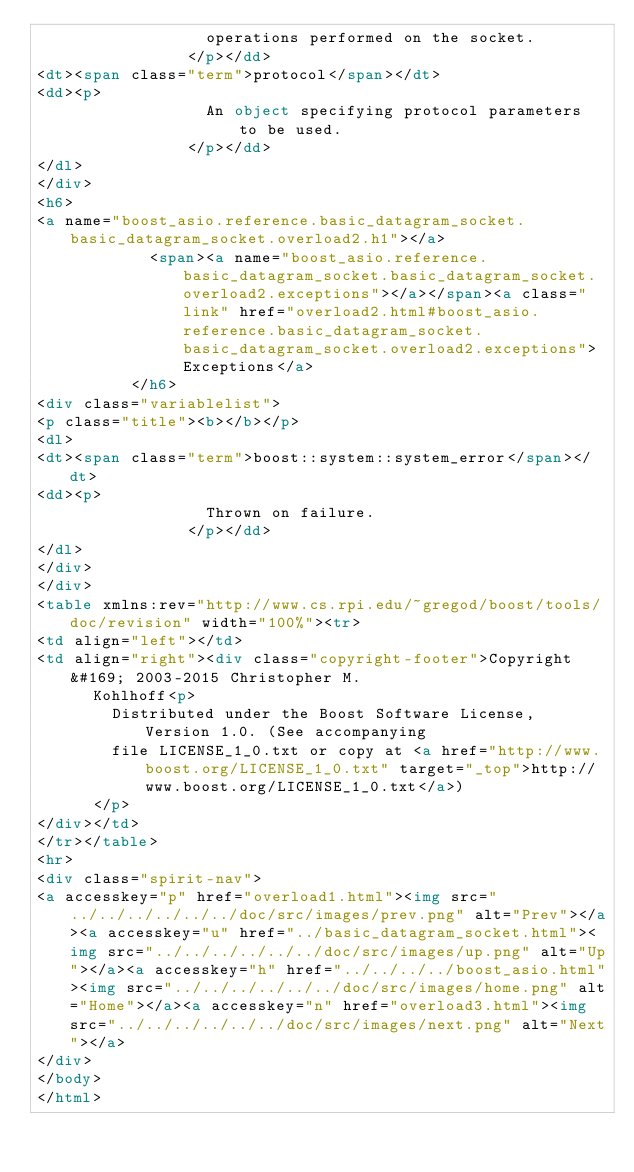<code> <loc_0><loc_0><loc_500><loc_500><_HTML_>                  operations performed on the socket.
                </p></dd>
<dt><span class="term">protocol</span></dt>
<dd><p>
                  An object specifying protocol parameters to be used.
                </p></dd>
</dl>
</div>
<h6>
<a name="boost_asio.reference.basic_datagram_socket.basic_datagram_socket.overload2.h1"></a>
            <span><a name="boost_asio.reference.basic_datagram_socket.basic_datagram_socket.overload2.exceptions"></a></span><a class="link" href="overload2.html#boost_asio.reference.basic_datagram_socket.basic_datagram_socket.overload2.exceptions">Exceptions</a>
          </h6>
<div class="variablelist">
<p class="title"><b></b></p>
<dl>
<dt><span class="term">boost::system::system_error</span></dt>
<dd><p>
                  Thrown on failure.
                </p></dd>
</dl>
</div>
</div>
<table xmlns:rev="http://www.cs.rpi.edu/~gregod/boost/tools/doc/revision" width="100%"><tr>
<td align="left"></td>
<td align="right"><div class="copyright-footer">Copyright &#169; 2003-2015 Christopher M.
      Kohlhoff<p>
        Distributed under the Boost Software License, Version 1.0. (See accompanying
        file LICENSE_1_0.txt or copy at <a href="http://www.boost.org/LICENSE_1_0.txt" target="_top">http://www.boost.org/LICENSE_1_0.txt</a>)
      </p>
</div></td>
</tr></table>
<hr>
<div class="spirit-nav">
<a accesskey="p" href="overload1.html"><img src="../../../../../../doc/src/images/prev.png" alt="Prev"></a><a accesskey="u" href="../basic_datagram_socket.html"><img src="../../../../../../doc/src/images/up.png" alt="Up"></a><a accesskey="h" href="../../../../boost_asio.html"><img src="../../../../../../doc/src/images/home.png" alt="Home"></a><a accesskey="n" href="overload3.html"><img src="../../../../../../doc/src/images/next.png" alt="Next"></a>
</div>
</body>
</html>
</code> 